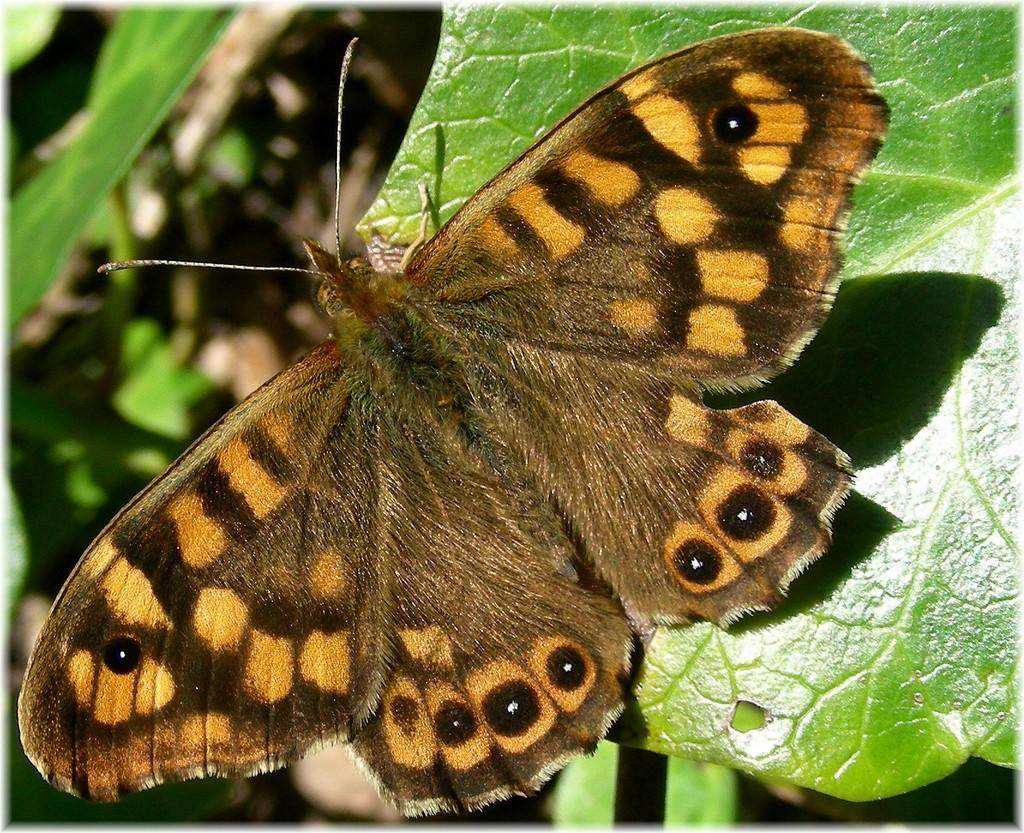What is the main subject of the image? There is a butterfly in the image. Can you describe the butterfly's appearance? The butterfly is brown in color. Where is the butterfly located in the image? The butterfly is sitting on a leaf. What color is the leaf? The leaf is green in color. What can be seen in the background of the image? There are plants in the background of the image. How many cents are visible on the butterfly in the image? There are no cents present in the image; it features a brown butterfly sitting on a green leaf. What type of scene is depicted in the image? The image depicts a butterfly sitting on a leaf with plants in the background, but it does not fit into a specific scene category. 